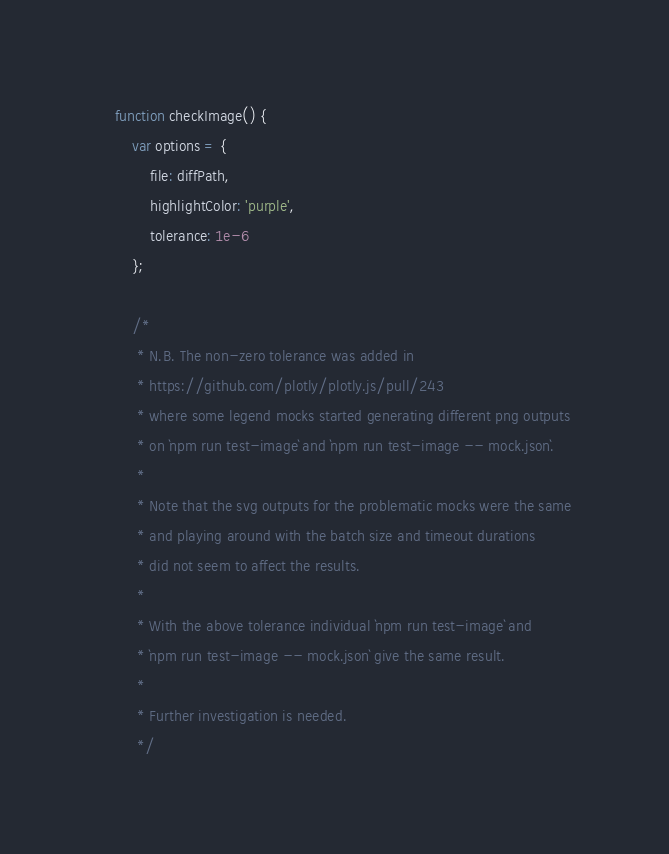<code> <loc_0><loc_0><loc_500><loc_500><_JavaScript_>
    function checkImage() {
        var options = {
            file: diffPath,
            highlightColor: 'purple',
            tolerance: 1e-6
        };

        /*
         * N.B. The non-zero tolerance was added in
         * https://github.com/plotly/plotly.js/pull/243
         * where some legend mocks started generating different png outputs
         * on `npm run test-image` and `npm run test-image -- mock.json`.
         *
         * Note that the svg outputs for the problematic mocks were the same
         * and playing around with the batch size and timeout durations
         * did not seem to affect the results.
         *
         * With the above tolerance individual `npm run test-image` and
         * `npm run test-image -- mock.json` give the same result.
         *
         * Further investigation is needed.
         */
</code> 